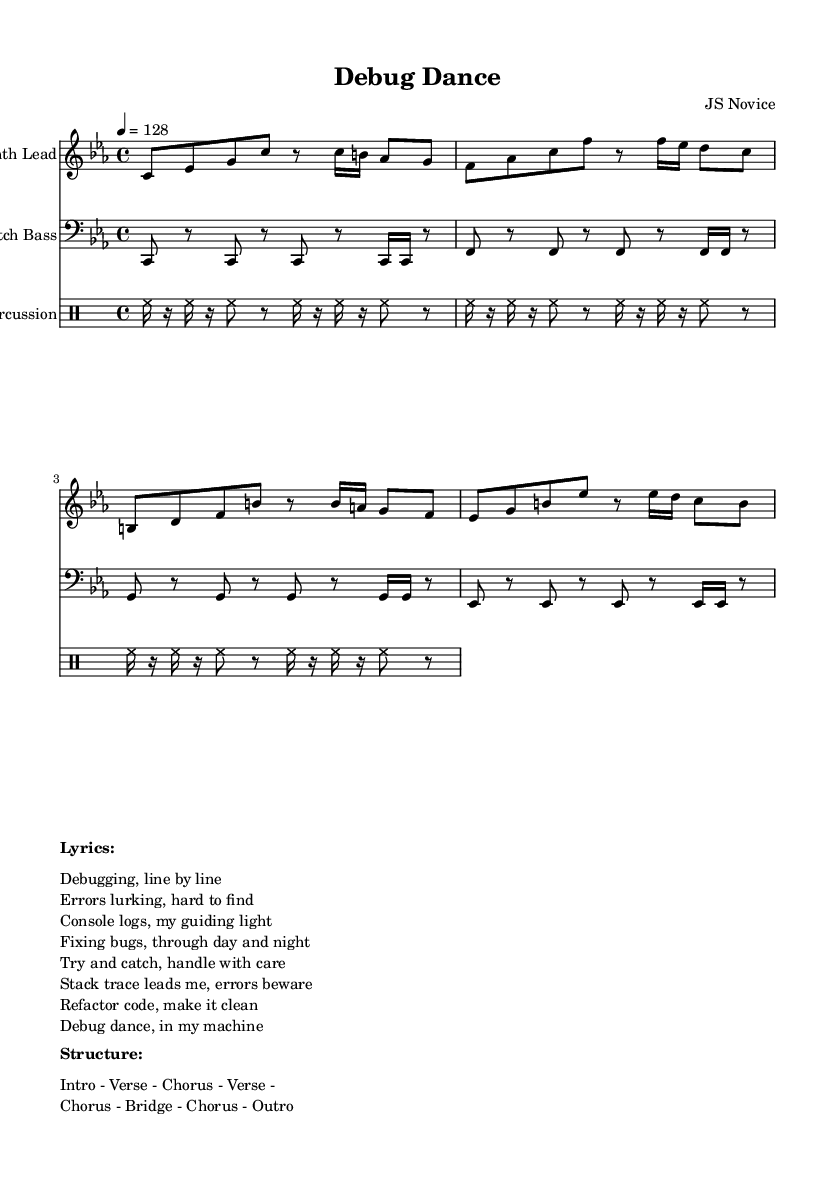What is the key signature of this music? The key signature is listed as C minor, which has three flats (B♭, E♭, and A♭) in its scale.
Answer: C minor What is the time signature of this piece? The time signature is indicated as 4/4, meaning there are four beats in each measure and the quarter note gets one beat.
Answer: 4/4 What is the tempo marking for the piece? The tempo marking of the piece is given as 128 beats per minute, indicated as “4 = 128” in the score.
Answer: 128 How many measures are in the Synth Lead section? By counting the measures indicated in the Synth Lead, there are a total of four measures present.
Answer: 4 What is the primary theme of the lyrics? The lyrics center around the acts of debugging and fixing errors in code, portraying the challenges faced during this process.
Answer: Debugging What instrument is represented in the second staff? The second staff is labeled as "Glitch Bass," indicating that it represents the bass instrumentation in the piece.
Answer: Glitch Bass What is the structure of the song? The structure specifies the order of sections in the song as “Intro - Verse - Chorus - Verse - Chorus - Bridge - Chorus - Outro.”
Answer: Intro - Verse - Chorus - Verse - Chorus - Bridge - Chorus - Outro 